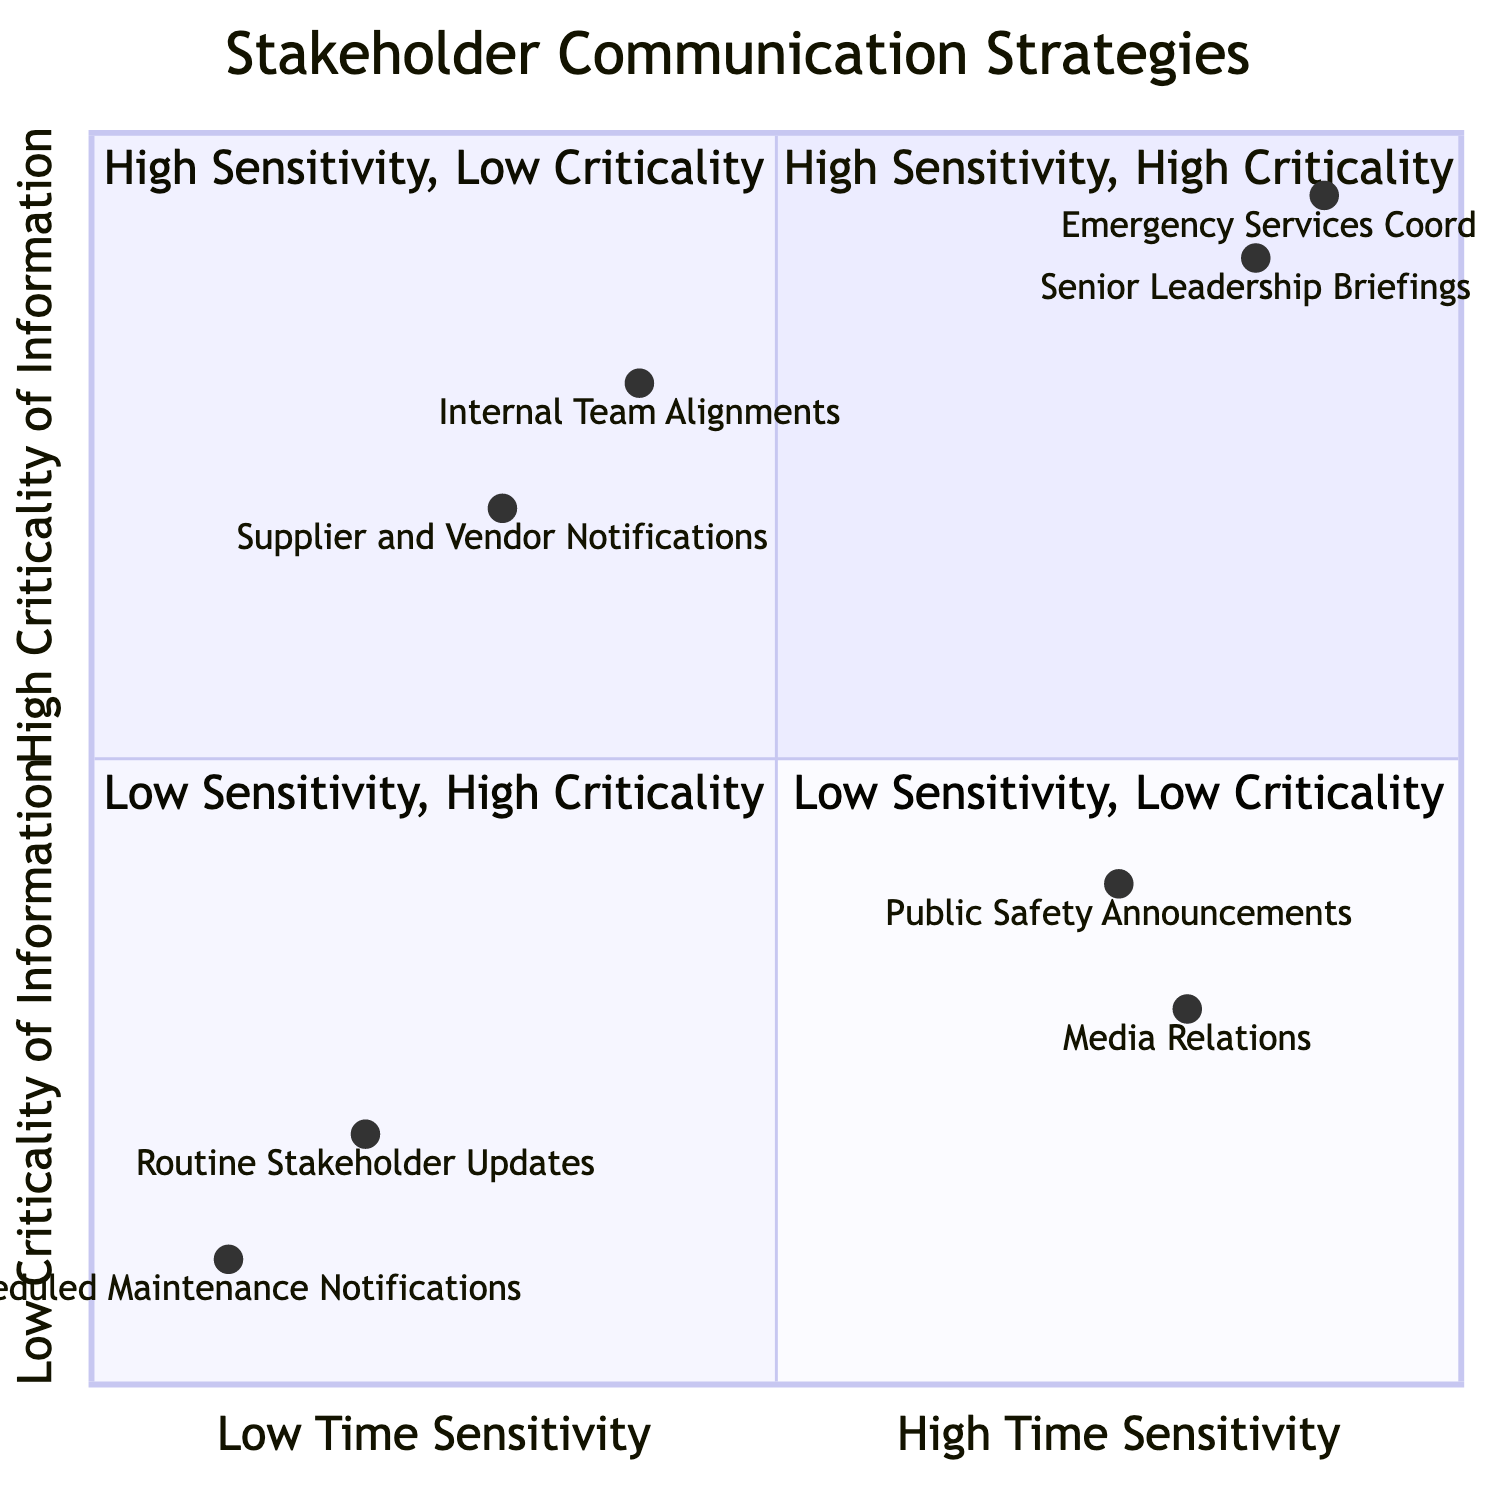What entities are located in Quadrant 1? Quadrant 1 of the diagram is labeled "High Sensitivity, High Criticality." The elements in this quadrant include "Emergency Services Coordination" and "Senior Leadership Briefings."
Answer: Emergency Services Coordination, Senior Leadership Briefings How many entities are in Quadrant 2? Quadrant 2 is labeled "High Sensitivity, Low Criticality" and contains two entities: "Media Relations" and "Public Safety Announcements." Therefore, there are two entities in this quadrant.
Answer: 2 Which entity has the highest time sensitivity? The time sensitivity values of the entities can be compared. "Emergency Services Coordination" has a time sensitivity value of 0.9, which is the highest among all listed entities.
Answer: Emergency Services Coordination What is the relationship between time sensitivity and criticality for "Internal Team Alignments"? "Internal Team Alignments" is located in Quadrant 3, which is characterized by Low Sensitivity and High Criticality. This indicates that while the time sensitivity is lower (0.4), the information is highly critical (0.8).
Answer: Low Sensitivity, High Criticality What is the lowest criticality value among the entities? The entities categorized in Quadrant 4 have the lowest criticality values, with "Scheduled Maintenance Notifications" having a criticality value of 0.1, which is the lowest among all entities in the diagram.
Answer: 0.1 How many quadrants focus on high sensitivity? Quadrants 1 and 2 are focused on high sensitivity: Quadrant 1 (High Sensitivity, High Criticality) and Quadrant 2 (High Sensitivity, Low Criticality). Thus, there are two quadrants that focus on high sensitivity.
Answer: 2 Which quadrant includes "Supplier and Vendor Notifications"? "Supplier and Vendor Notifications" is located in Quadrant 3, which is labeled "Low Sensitivity, High Criticality." This information can be confirmed by observing the quadrant's elements.
Answer: Quadrant 3 What is the combined total of criticality values for Quadrant 4 entities? The criticality values for the entities in Quadrant 4, "Routine Stakeholder Updates" (0.2) and "Scheduled Maintenance Notifications" (0.1), sum to 0.3 when combined.
Answer: 0.3 